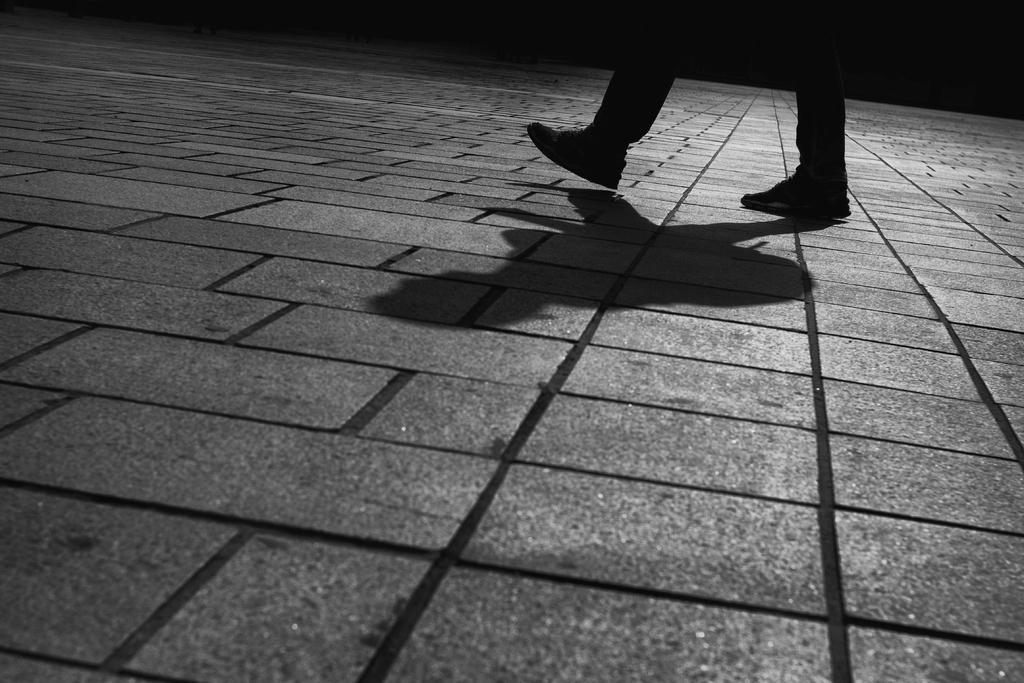Could you give a brief overview of what you see in this image? In this image, we can see the legs of a person. We can also see the ground with the shadow. 